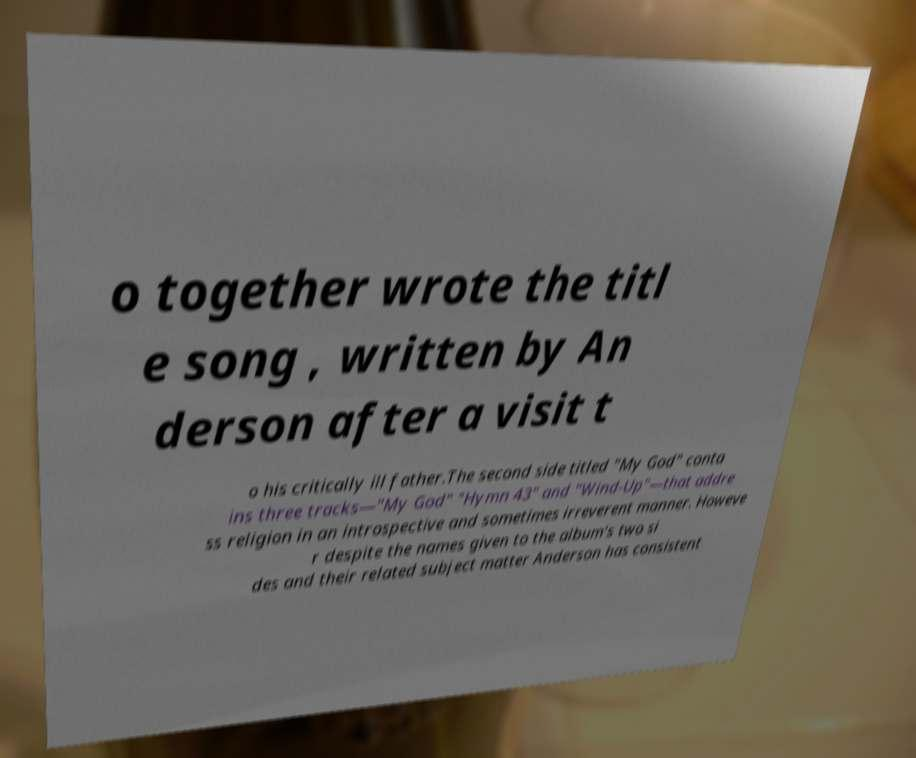What messages or text are displayed in this image? I need them in a readable, typed format. o together wrote the titl e song , written by An derson after a visit t o his critically ill father.The second side titled "My God" conta ins three tracks—"My God" "Hymn 43" and "Wind-Up"—that addre ss religion in an introspective and sometimes irreverent manner. Howeve r despite the names given to the album's two si des and their related subject matter Anderson has consistent 